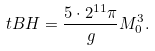Convert formula to latex. <formula><loc_0><loc_0><loc_500><loc_500>\ t B H = \frac { 5 \cdot 2 ^ { 1 1 } \pi } { g } M _ { 0 } ^ { 3 } .</formula> 